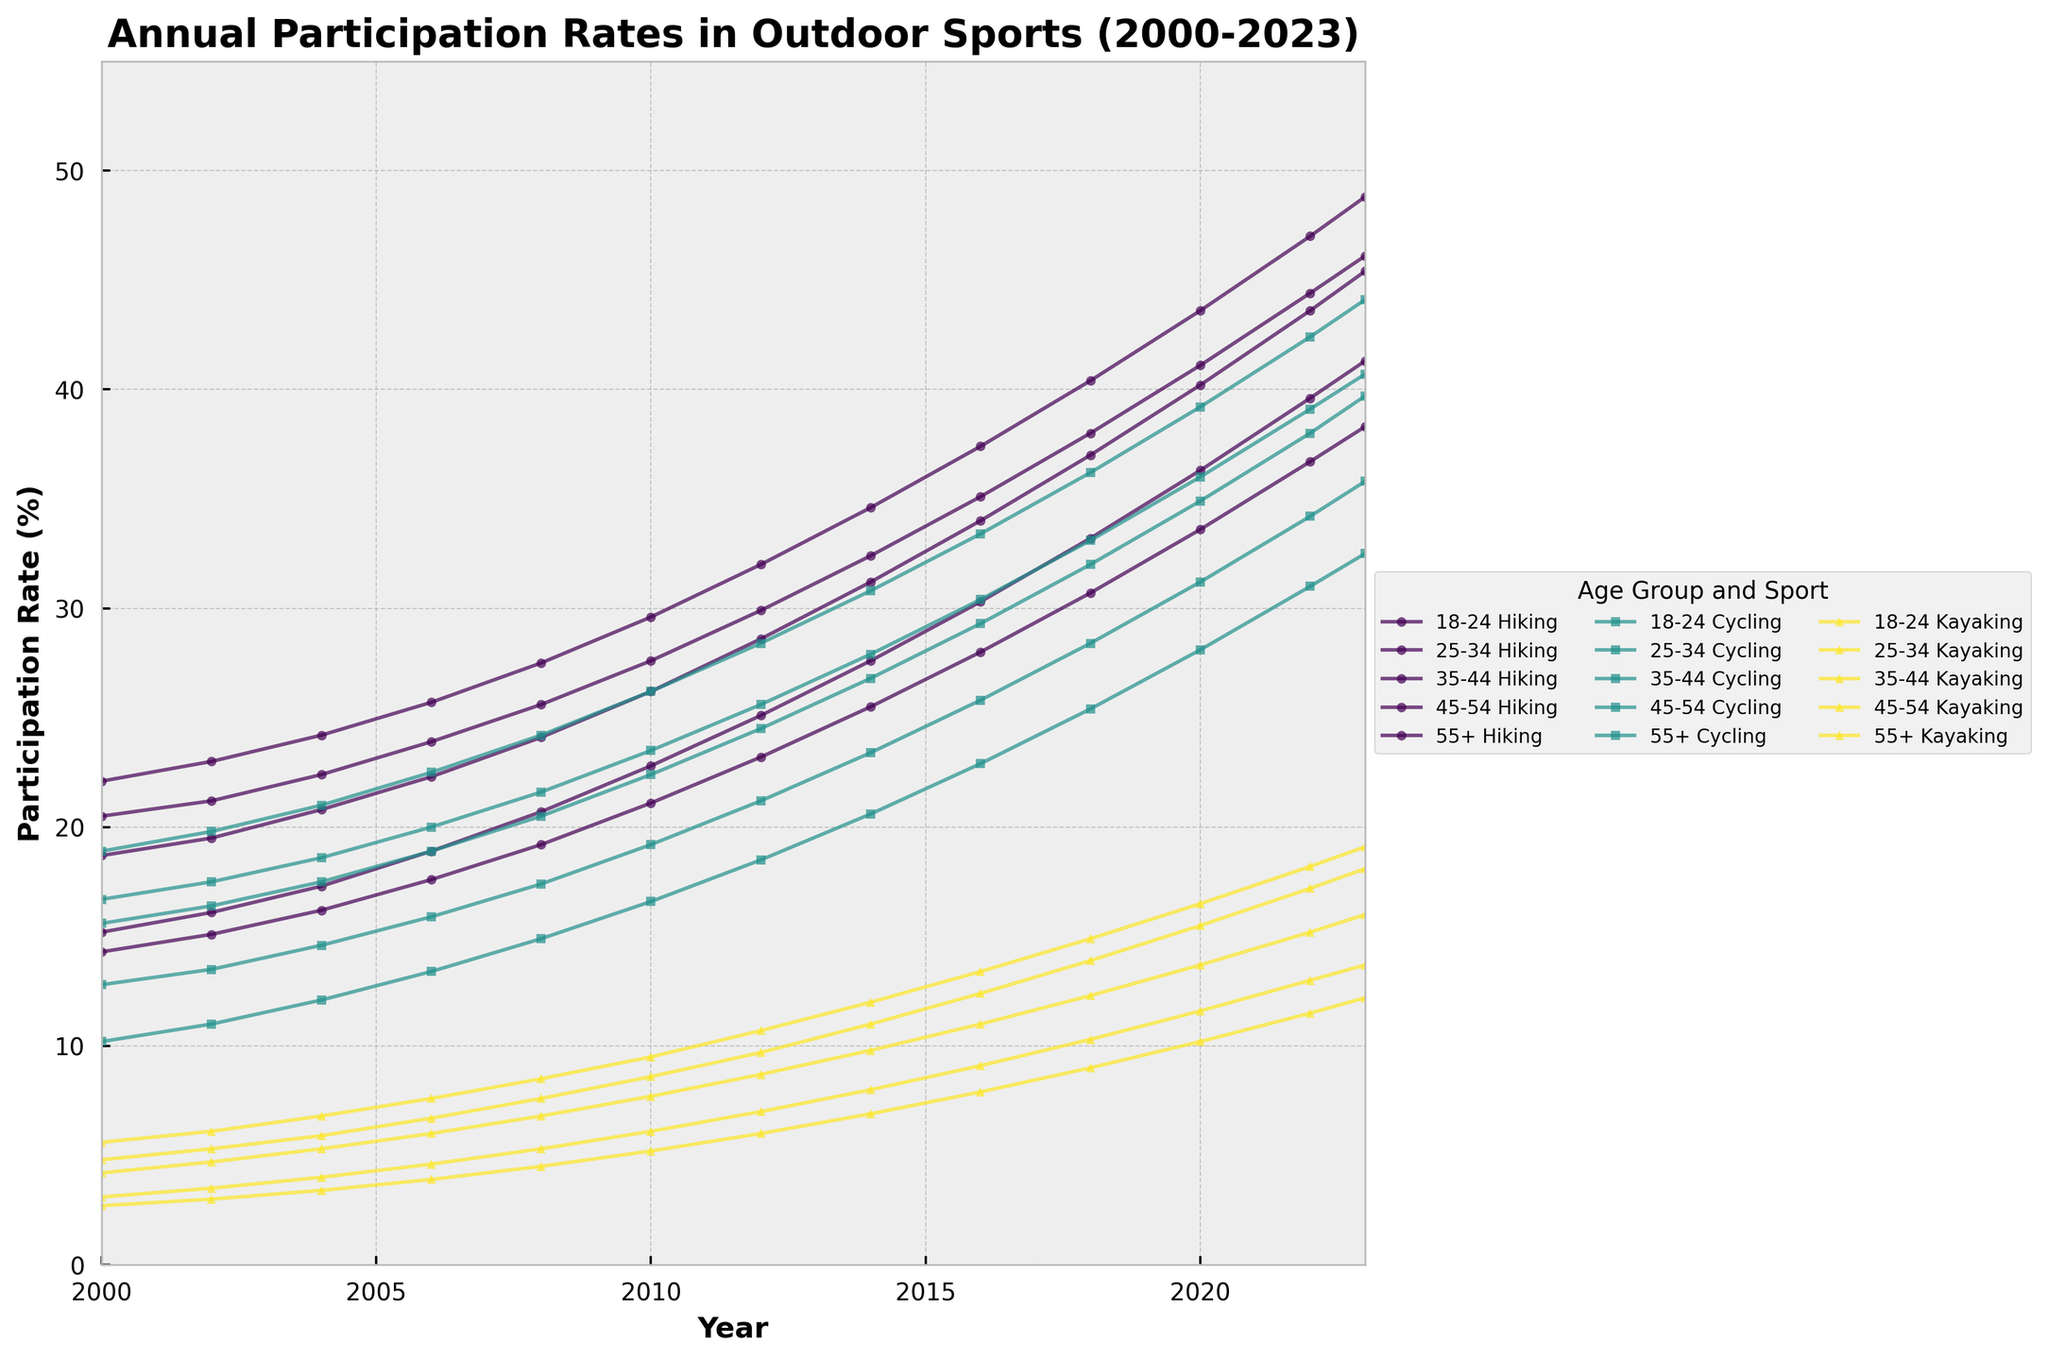Which age group had the highest participation rate in kayaking in 2023? Look at the end of the chart for the kayaking lines in 2023 and compare the heights. The 18-24 age group's line is the highest.
Answer: 18-24 How did the participation rate in cycling for the 25-34 age group change from 2000 to 2023? Find the starting and ending points for the 25-34 cycling line and calculate the difference. In 2000, it was 15.6%, and in 2023, it was 39.7%. The change is 39.7% - 15.6% = 24.1%.
Answer: Increased by 24.1% What is the average participation rate in hiking for the 45-54 age group from 2000 to 2023? Sum the values for the 45-54 hiking group for each available year and divide by the number of years. Values: 20.5, 21.2, 22.4, 23.9, 25.6, 27.6, 29.9, 32.4, 35.1, 38.0, 41.1, 44.4, 46.1. Sum is 408.2. Divide by 13 years: 408.2 / 13 = 31.4.
Answer: 31.4% Compare the participation rates in cycling for the 55+ age group in 2010 and 2023. Which year had a higher rate, and by how much? Locate the 55+ cycling line and compare the values at 2010 (16.6%) and 2023 (32.5%). Subtract to find the difference: 32.5% - 16.6% = 15.9%.
Answer: 2023 had a higher rate by 15.9% Was the participation rate in hiking for the 18-24 age group ever below 20% after the year 2008? Scan the hiking lines for the 18-24 age group after 2008 and check if any value is below 20%. After 2008, the rates are consistently above 20%.
Answer: No Which sport showed the fastest-growing participation rate for the 35-44 age group from 2000 to 2023? Compare the slopes of the lines for hiking, cycling, and kayaking for the 35-44 age group. Kayaking shows the steepest rise.
Answer: Kayaking By how much did the participation rate in kayaking for the 55+ age group change from 2020 to 2023? Look at the values for 2020 (10.2%) and 2023 (12.2%) for the 55+ kayaking line. Calculate the difference: 12.2% - 10.2% = 2%.
Answer: 2% What is the total increase in participation rate in hiking for the 35-44 age group from 2000 to 2023? Find the hiking rates for the 35-44 age group in 2000 (22.1%) and 2023 (48.8%). Calculate the increase: 48.8% - 22.1% = 26.7%.
Answer: 26.7% Which age group saw the least change in their participation rate in cycling from 2000 to 2023? Compare the changes by calculating the difference in rates for all age groups in cycling. The 18-24 age group had the smallest increase, from 12.8% to 35.8%, which is an increase of 23%.
Answer: 18-24 Did the participation rate in hiking for the 55+ age group exceed 35% in 2023? Look for the value at 2023 on the 55+ hiking line. It reads 38.3%, which exceeds 35%.
Answer: Yes 